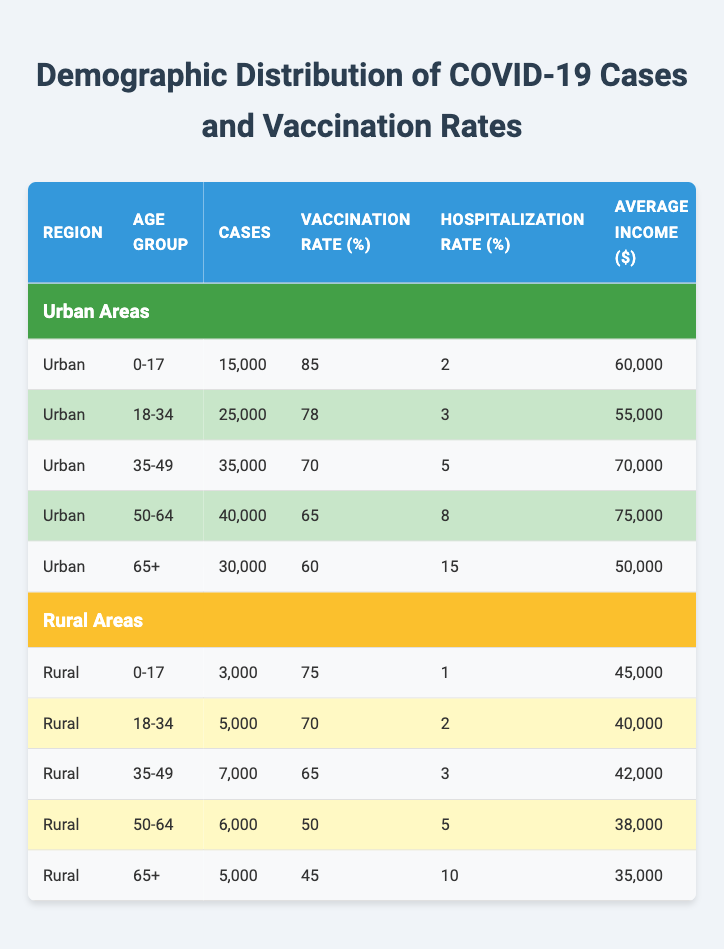What is the vaccination rate for the age group 50-64 in urban areas? Referring to the table, the vaccination rate for the age group 50-64 in urban areas is listed as 65%.
Answer: 65% What is the total number of COVID-19 cases in rural areas for the age group 18-34? The table shows that there are 5,000 cases for the age group 18-34 in rural areas.
Answer: 5,000 Are there more COVID-19 cases in the urban age group 35-49 or the rural age group 35-49? The table states that there are 35,000 cases in urban areas for the age group 35-49 and 7,000 cases in rural areas for the same age group. Therefore, urban has more cases.
Answer: Yes What is the average hospitalization rate for the age groups 0-17 and 65+ in rural areas? The hospitalization rates for 0-17 and 65+ in rural areas are 1% and 10%, respectively. The average is (1 + 10) / 2 = 5.5%.
Answer: 5.5% How does the average income compare between urban and rural areas for the 50-64 age group? The average income for the 50-64 age group in urban areas is $75,000, while in rural areas it is $38,000. The urban average is higher by $37,000.
Answer: $37,000 What is the difference in vaccination rates between the 0-17 age group in urban and rural areas? The vaccination rate for the 0-17 age group in urban areas is 85%, while in rural areas it is 75%. The difference is 85% - 75% = 10%.
Answer: 10% Which age group has the highest hospitalization rate in urban areas? The hospitalization rates for urban areas show that the age group 65+ has the highest rate at 15%.
Answer: 15% Is the population density in urban areas higher than in rural areas for all age groups? Yes, the table indicates that urban areas have a population density of 12,000 per sq km, while rural areas have a density of 100 per sq km across all age groups.
Answer: Yes What is the total number of cases across all age groups in rural areas? The total cases in rural areas are the sum of cases across all age groups: 3,000 + 5,000 + 7,000 + 6,000 + 5,000 = 26,000.
Answer: 26,000 What age group in urban areas has the lowest vaccination rate and what is that rate? In the urban areas, the age group 65+ has the lowest vaccination rate at 60%.
Answer: 60% Which region has a higher number of cases for the age group 18-34, urban or rural? According to the table, urban areas have 25,000 cases for the age group 18-34, while rural areas have 5,000. Urban has more cases.
Answer: Urban 